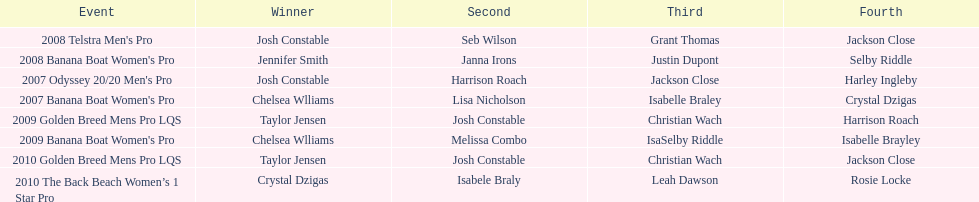What is the overall count of chelsea williams' victories from 2007 to 2010? 2. 